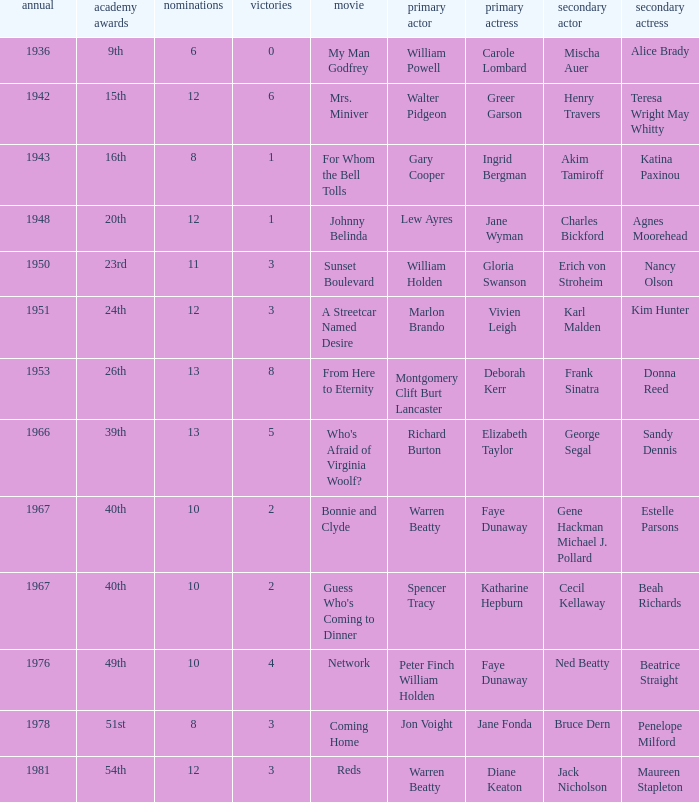Who was the supporting actress in 1943? Katina Paxinou. 